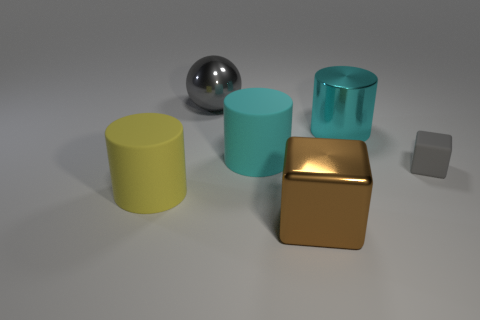Add 3 big cyan metallic cylinders. How many objects exist? 9 Subtract all balls. How many objects are left? 5 Add 3 big rubber objects. How many big rubber objects are left? 5 Add 3 big rubber balls. How many big rubber balls exist? 3 Subtract 0 green spheres. How many objects are left? 6 Subtract all gray matte things. Subtract all big cyan matte cylinders. How many objects are left? 4 